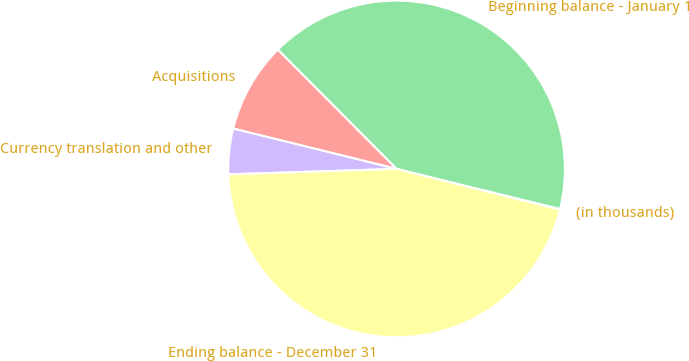Convert chart. <chart><loc_0><loc_0><loc_500><loc_500><pie_chart><fcel>(in thousands)<fcel>Beginning balance - January 1<fcel>Acquisitions<fcel>Currency translation and other<fcel>Ending balance - December 31<nl><fcel>0.07%<fcel>41.29%<fcel>8.68%<fcel>4.37%<fcel>45.59%<nl></chart> 